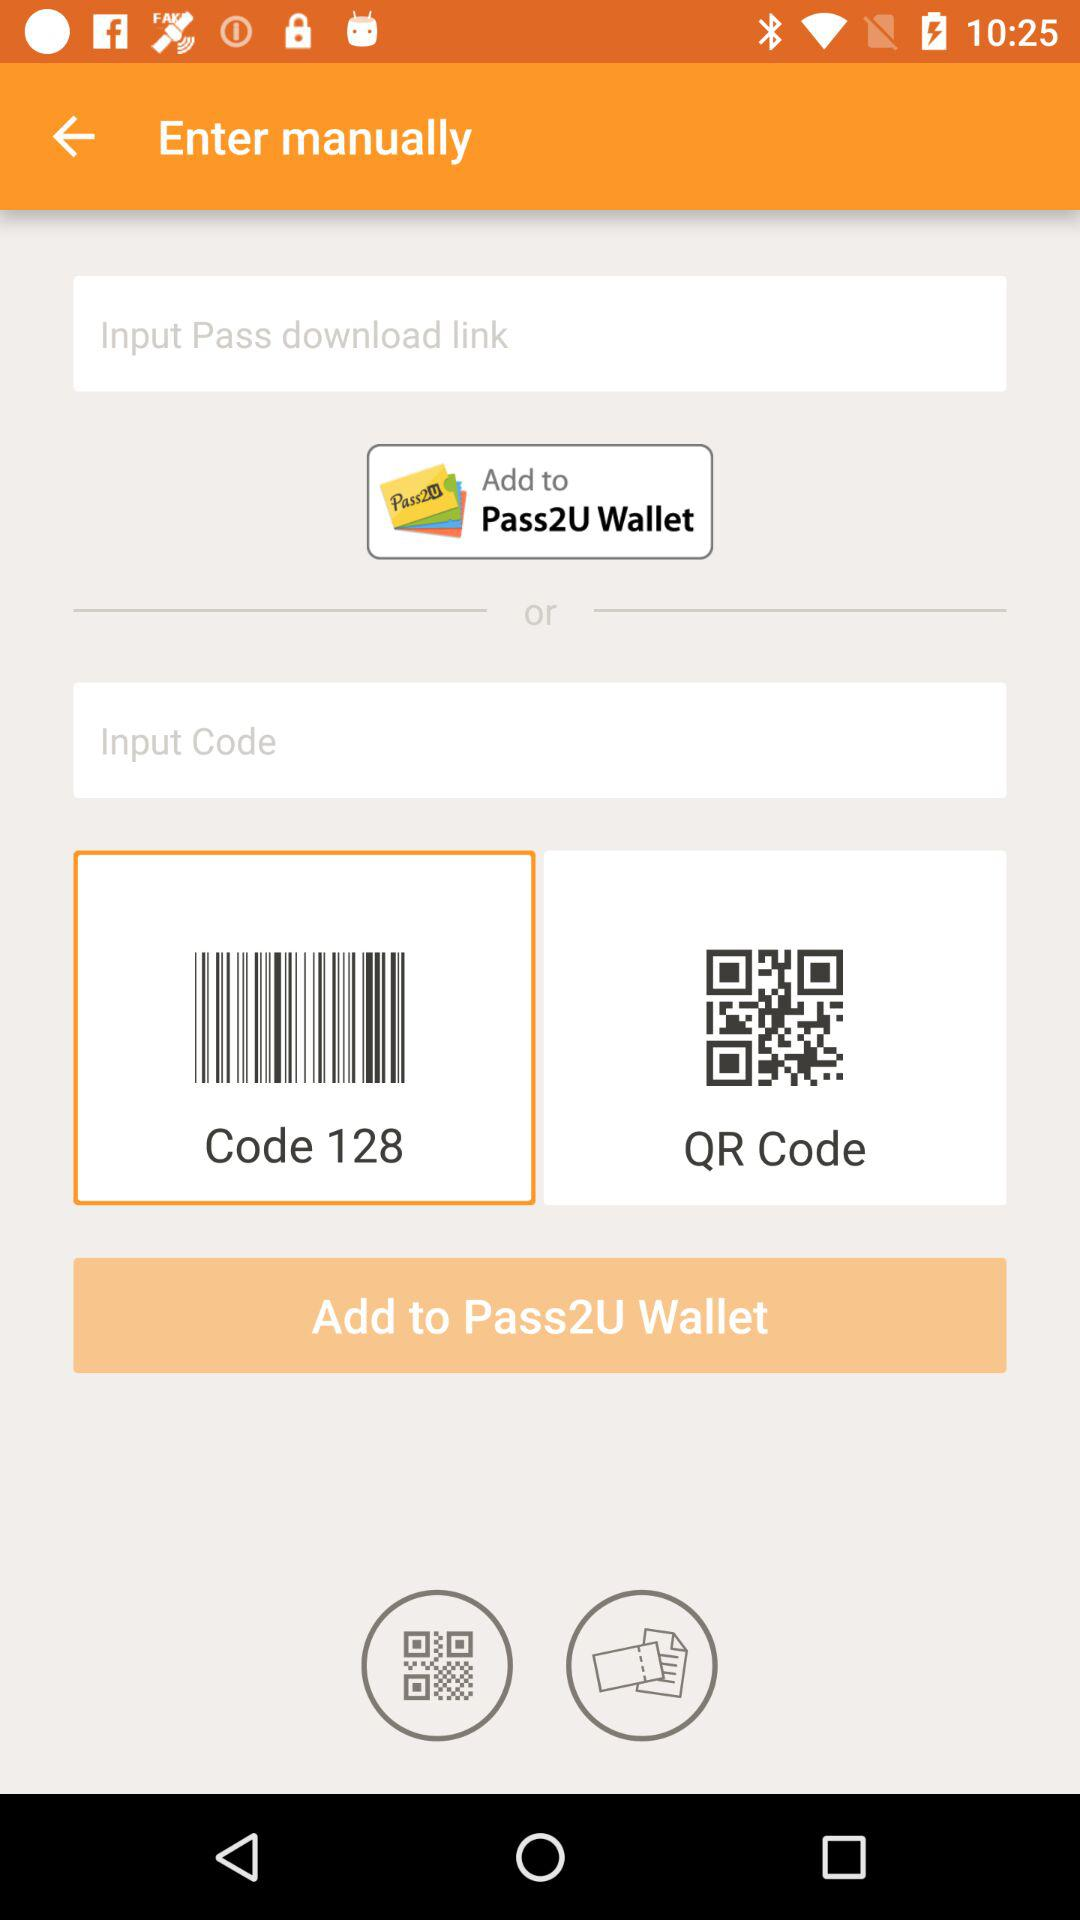Where to add cards or coupons? Cards or coupons are to be added to the "Pass2U Wallet". 